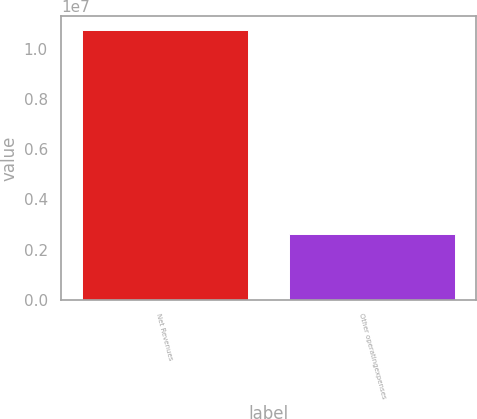Convert chart to OTSL. <chart><loc_0><loc_0><loc_500><loc_500><bar_chart><fcel>Net Revenues<fcel>Other operatingexpenses<nl><fcel>1.07578e+07<fcel>2.60023e+06<nl></chart> 